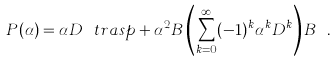<formula> <loc_0><loc_0><loc_500><loc_500>P ( \alpha ) = \alpha D ^ { \ } t r a s p + \alpha ^ { 2 } B \left ( \sum _ { k = 0 } ^ { \infty } ( - 1 ) ^ { k } \alpha ^ { k } D ^ { k } \right ) B ^ { \dag } \, .</formula> 